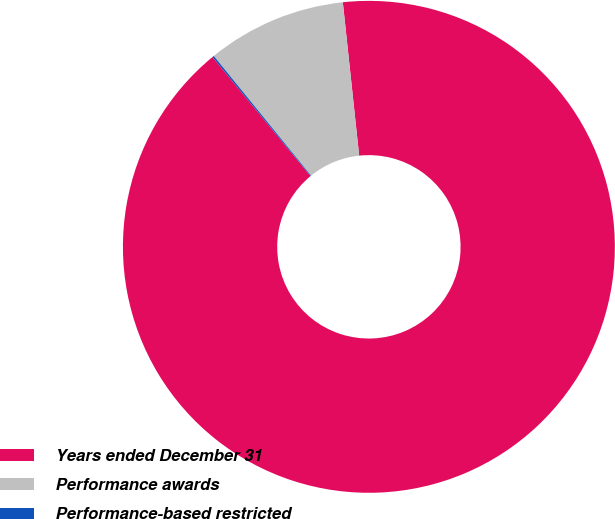<chart> <loc_0><loc_0><loc_500><loc_500><pie_chart><fcel>Years ended December 31<fcel>Performance awards<fcel>Performance-based restricted<nl><fcel>90.71%<fcel>9.17%<fcel>0.11%<nl></chart> 